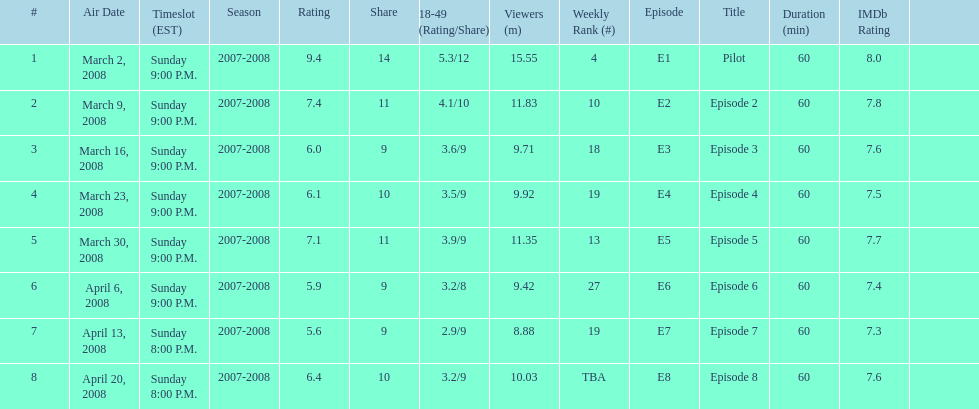What episode had the highest rating? March 2, 2008. 